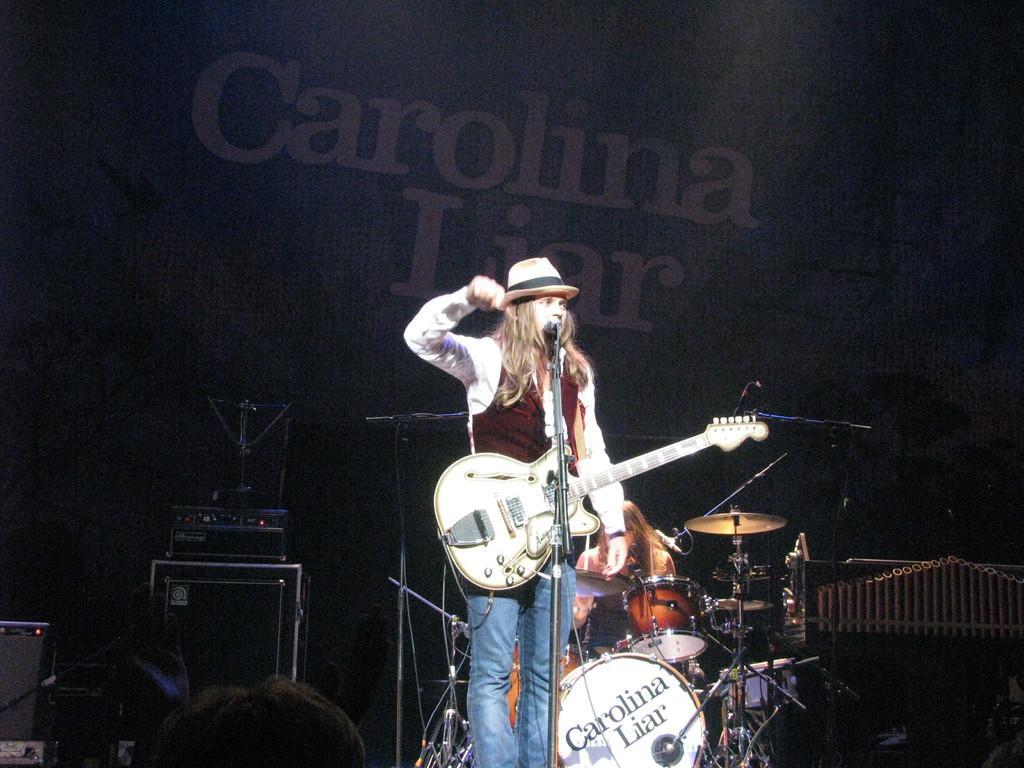In one or two sentences, can you explain what this image depicts? In this image i can see a person standing and holding a musical instrument, there is a micro phone in front of a person there are few musical instrument at the back ground i can see a board. 